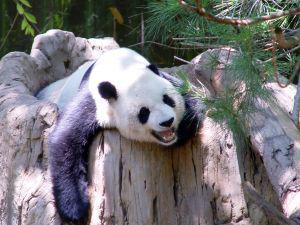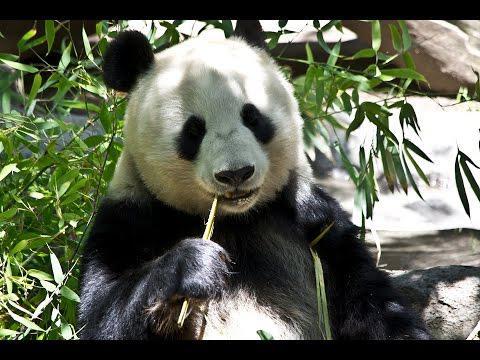The first image is the image on the left, the second image is the image on the right. For the images shown, is this caption "One panda image features an expanse of green lawn in the background." true? Answer yes or no. No. 